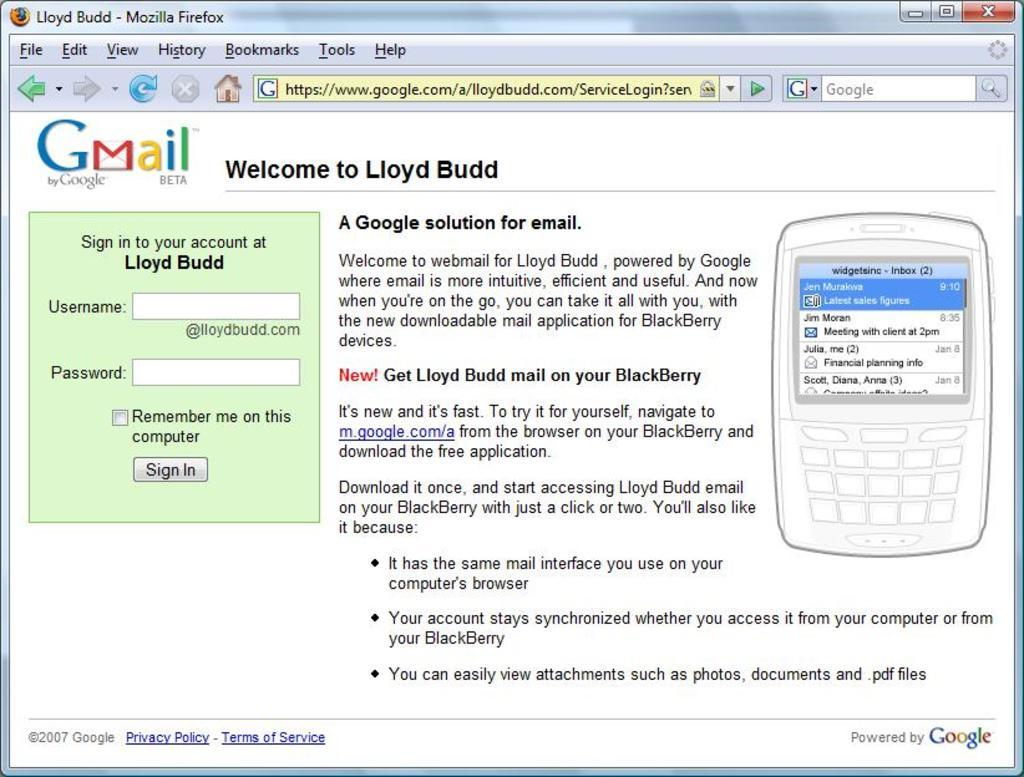<image>
Give a short and clear explanation of the subsequent image. A Gmail screen shot welcoming Lloyd Budd asking for Username and Password. 